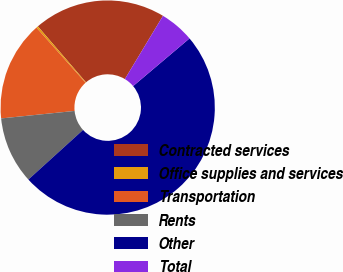<chart> <loc_0><loc_0><loc_500><loc_500><pie_chart><fcel>Contracted services<fcel>Office supplies and services<fcel>Transportation<fcel>Rents<fcel>Other<fcel>Total<nl><fcel>19.94%<fcel>0.28%<fcel>15.03%<fcel>10.11%<fcel>49.44%<fcel>5.2%<nl></chart> 